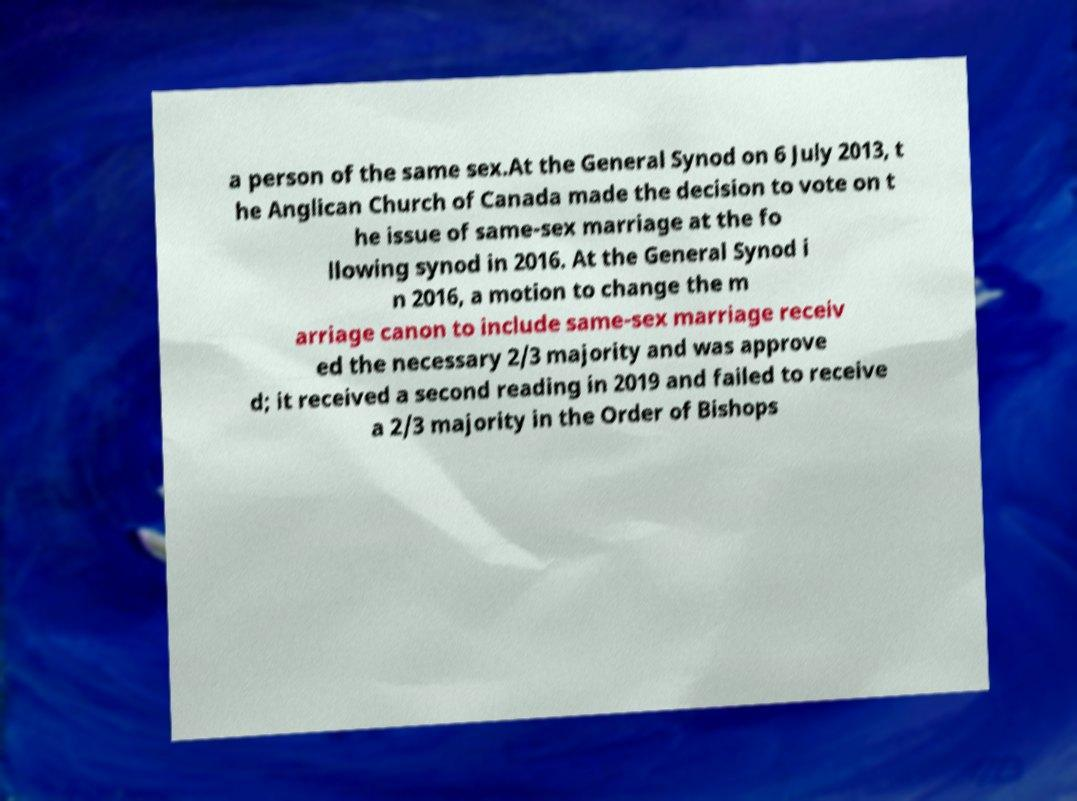I need the written content from this picture converted into text. Can you do that? a person of the same sex.At the General Synod on 6 July 2013, t he Anglican Church of Canada made the decision to vote on t he issue of same-sex marriage at the fo llowing synod in 2016. At the General Synod i n 2016, a motion to change the m arriage canon to include same-sex marriage receiv ed the necessary 2/3 majority and was approve d; it received a second reading in 2019 and failed to receive a 2/3 majority in the Order of Bishops 